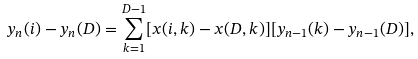<formula> <loc_0><loc_0><loc_500><loc_500>y _ { n } ( i ) - y _ { n } ( D ) = \sum _ { k = 1 } ^ { D - 1 } [ x ( i , k ) - x ( D , k ) ] [ y _ { n - 1 } ( k ) - y _ { n - 1 } ( D ) ] ,</formula> 